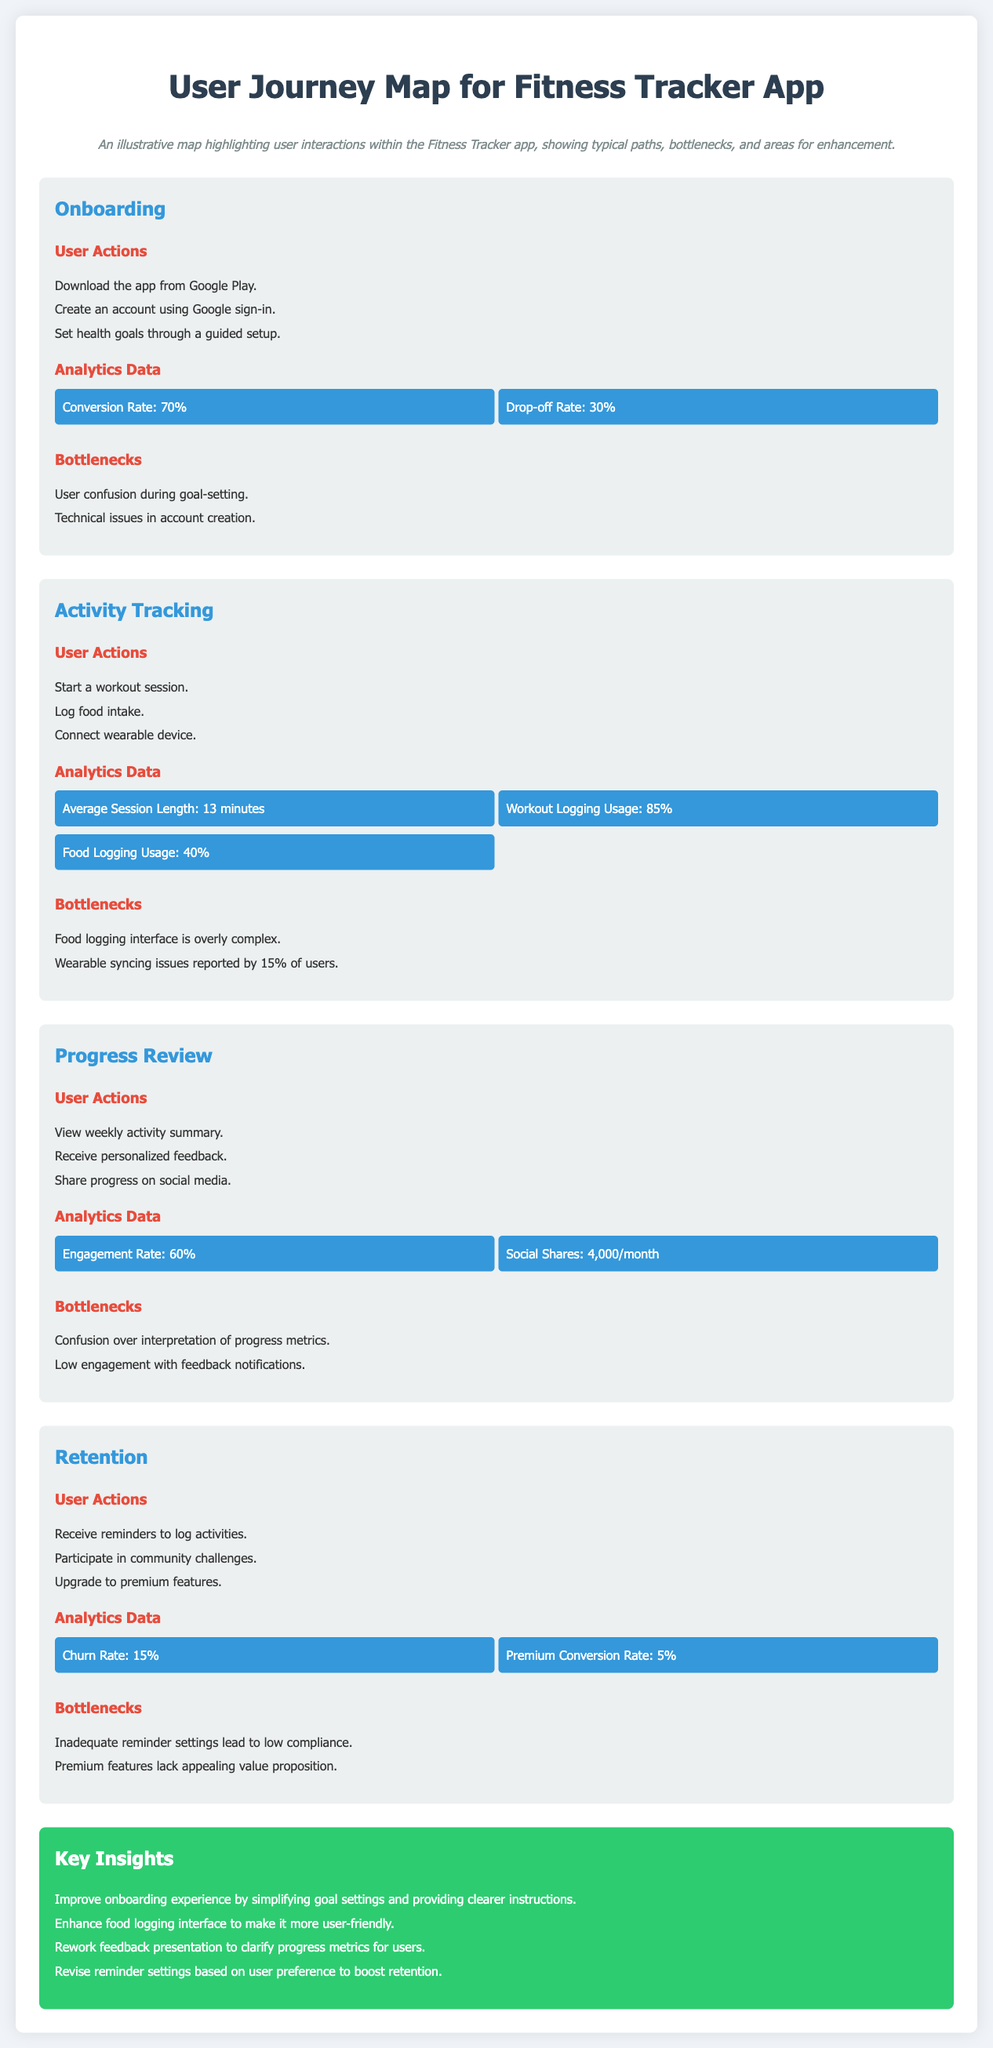what is the conversion rate during onboarding? The conversion rate is provided in the analytics data for the onboarding stage.
Answer: 70% what is the drop-off rate during onboarding? The drop-off rate is provided in the analytics data for the onboarding stage.
Answer: 30% what is the average session length during activity tracking? The average session length is provided in the analytics data for the activity tracking stage.
Answer: 13 minutes how many users participate in social sharing monthly? The number of users sharing progress on social media is given in the analytics data for the progress review stage.
Answer: 4,000/month what is the churn rate in the retention stage? The churn rate is provided in the analytics data for the retention stage.
Answer: 15% what is a bottleneck experienced during the onboarding stage? A bottleneck is identified in the onboarding section and relates to user confusion.
Answer: User confusion during goal-setting what is the food logging usage percentage? The food logging usage is found in the analytics data of the activity tracking stage.
Answer: 40% how can the onboarding experience be improved? The key insights recommend specific improvements to the onboarding experience based on the overall analysis.
Answer: Simplifying goal settings and providing clearer instructions what percentage of users report wearable syncing issues? The percentage of users reporting issues is stated in the bottlenecks for activity tracking.
Answer: 15% 